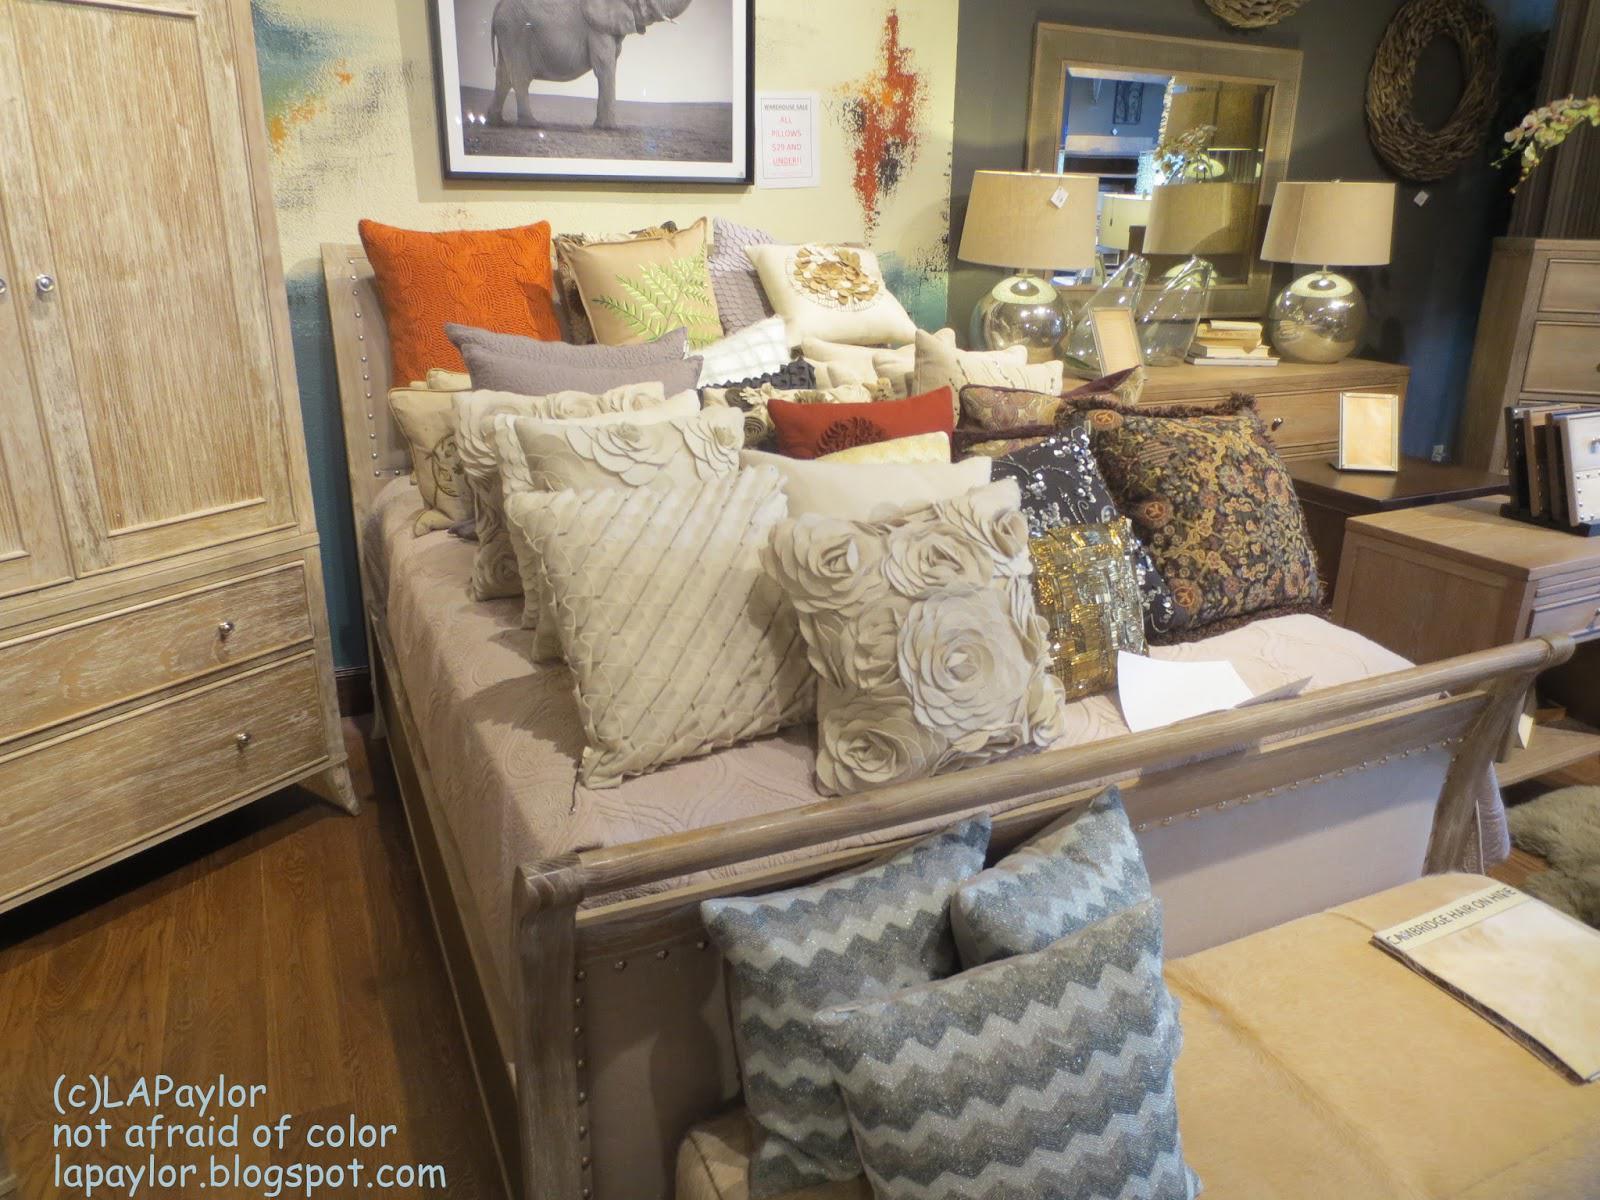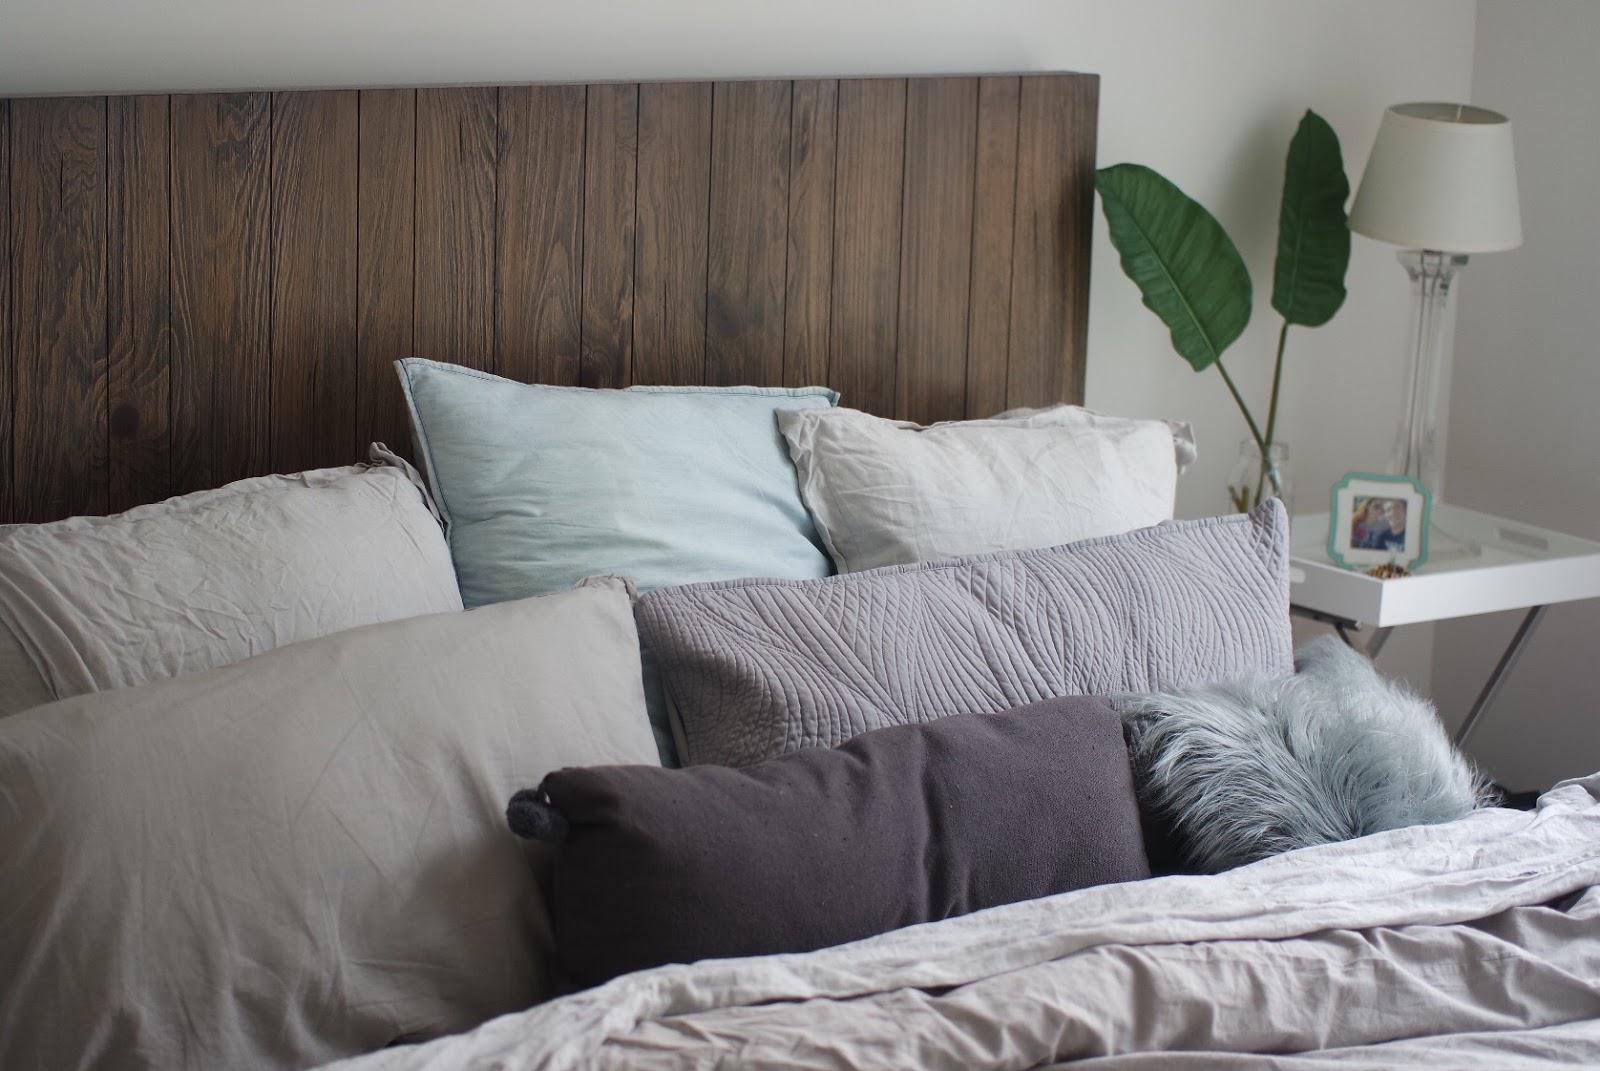The first image is the image on the left, the second image is the image on the right. Examine the images to the left and right. Is the description "All bedding and pillows in one image are white." accurate? Answer yes or no. No. The first image is the image on the left, the second image is the image on the right. Assess this claim about the two images: "there is exactly one lamp in one of the images.". Correct or not? Answer yes or no. Yes. 